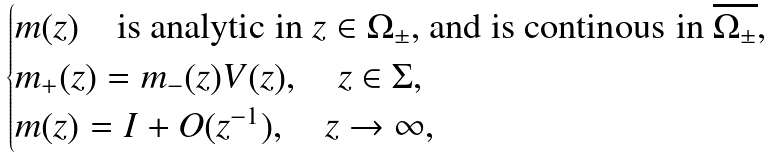Convert formula to latex. <formula><loc_0><loc_0><loc_500><loc_500>\begin{cases} m ( z ) \quad \text {is analytic in $z\in \Omega_{\pm}$, and is continous in $\overline{\Omega_{\pm}}$,} \\ m _ { + } ( z ) = m _ { - } ( z ) V ( z ) , \quad z \in \Sigma , \\ m ( z ) = I + O ( z ^ { - 1 } ) , \quad z \to \infty , \end{cases}</formula> 